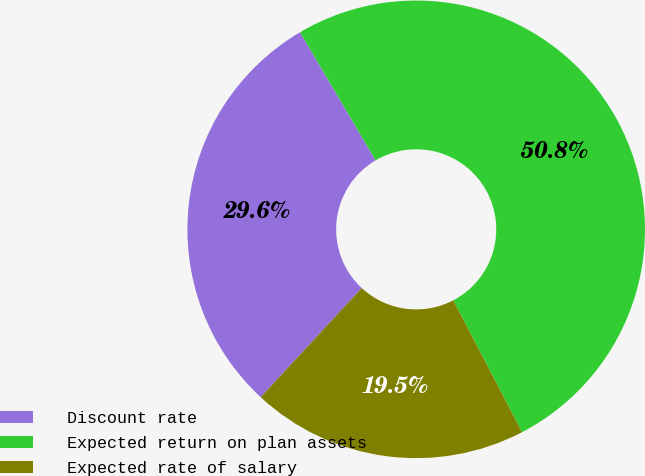Convert chart. <chart><loc_0><loc_0><loc_500><loc_500><pie_chart><fcel>Discount rate<fcel>Expected return on plan assets<fcel>Expected rate of salary<nl><fcel>29.63%<fcel>50.82%<fcel>19.55%<nl></chart> 